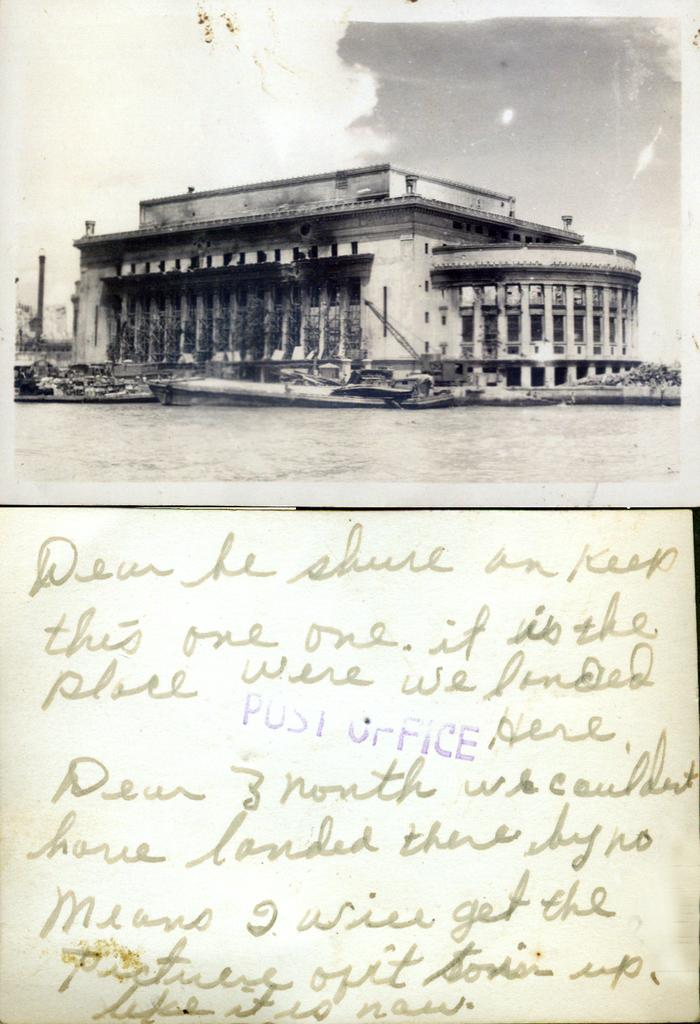<image>
Present a compact description of the photo's key features. An old photograph is above a hand written letter with a post office stamp on it. 